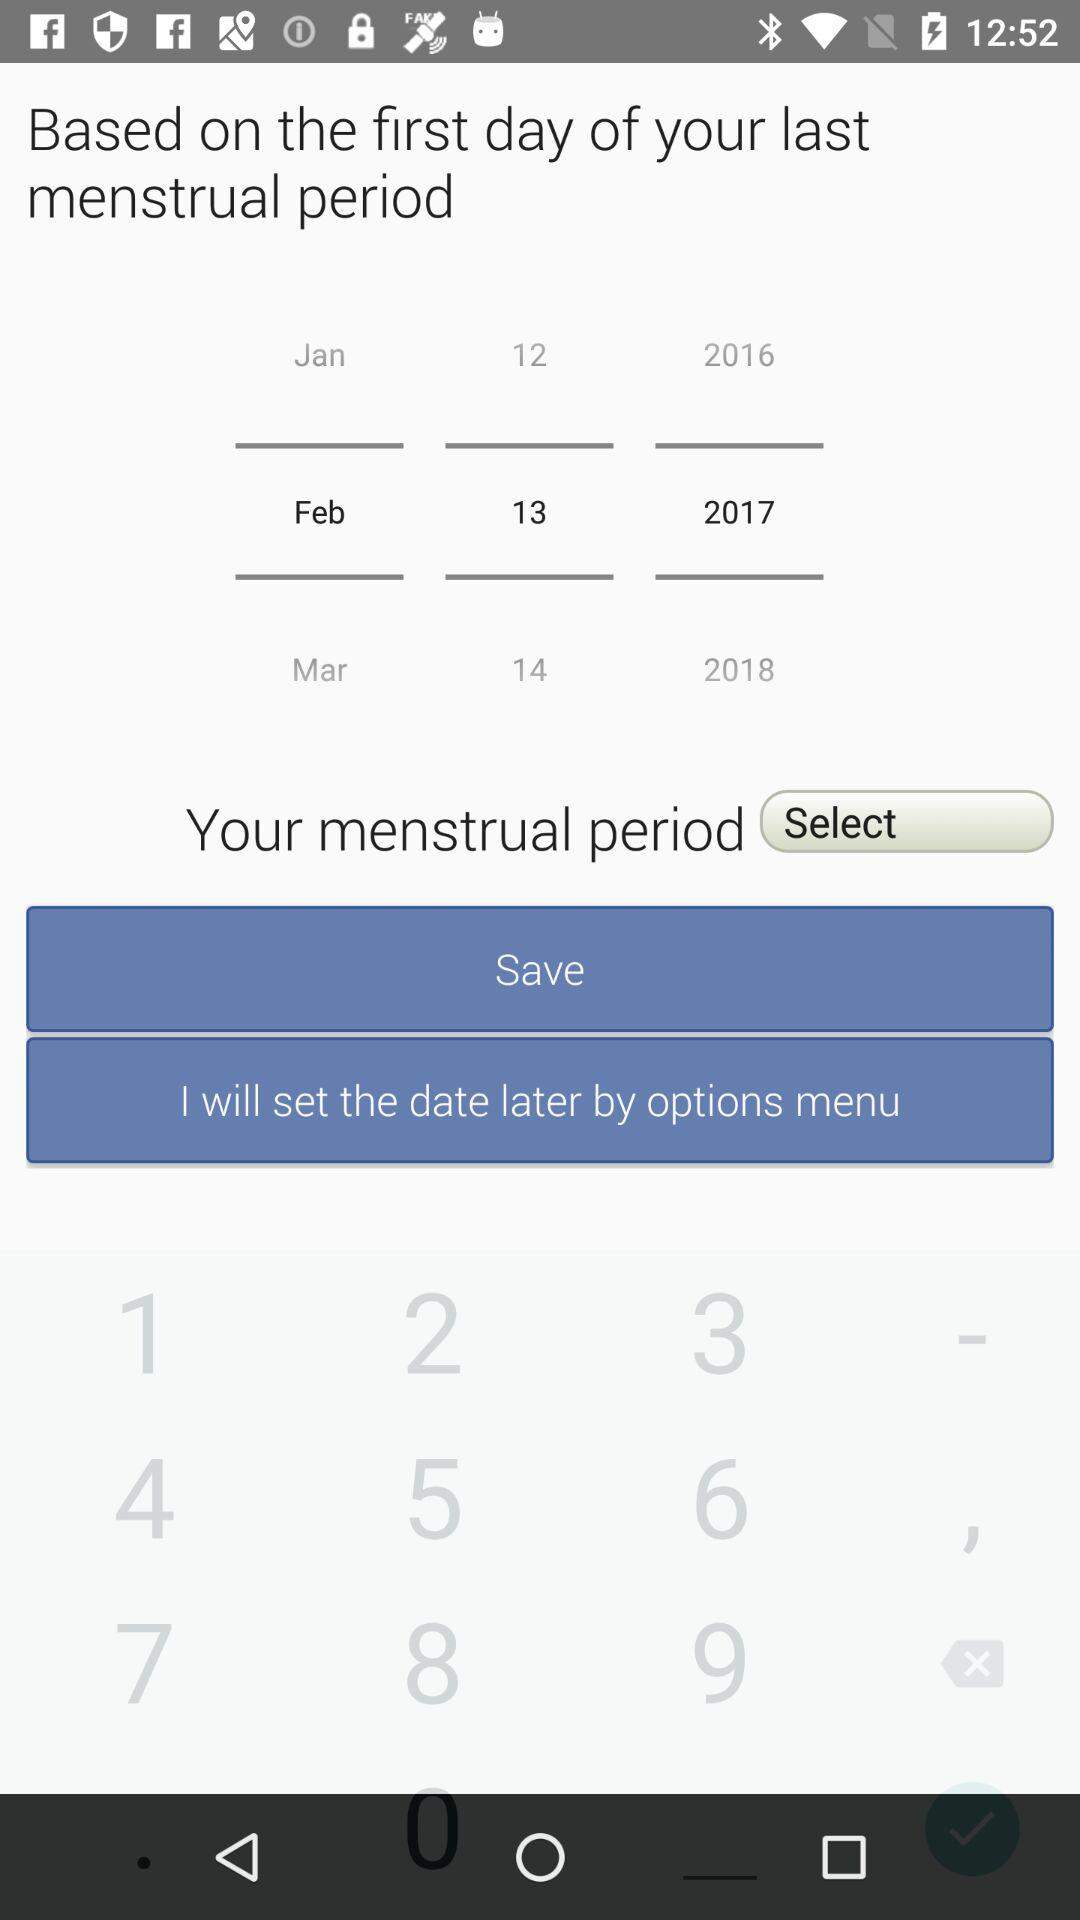Which date is selected? The selected date is February 13, 2017. 